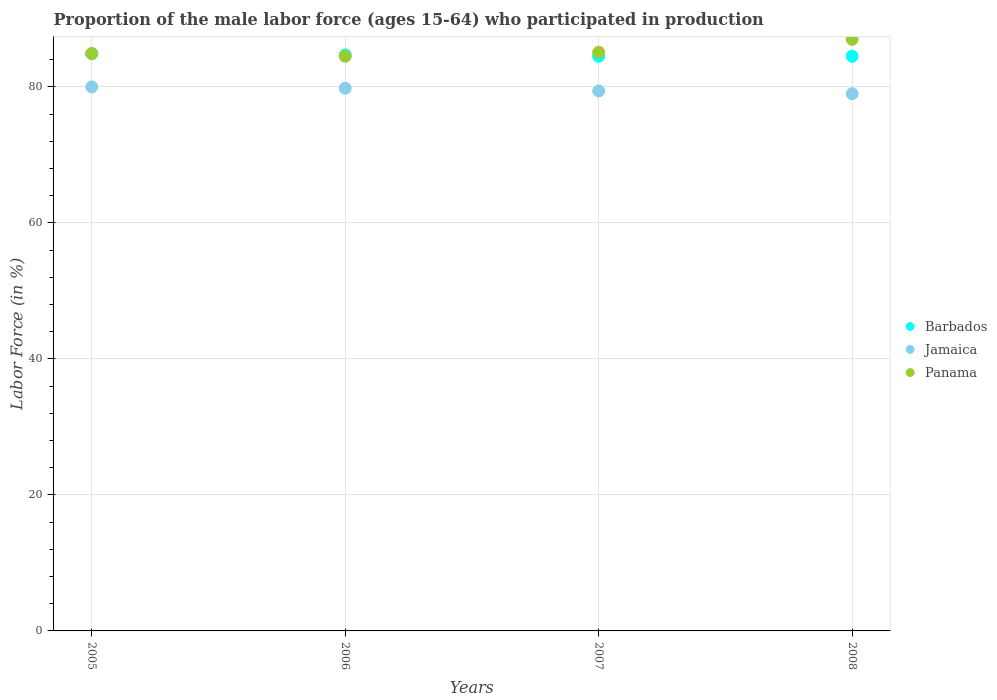How many different coloured dotlines are there?
Your answer should be very brief. 3. Is the number of dotlines equal to the number of legend labels?
Offer a very short reply. Yes. What is the proportion of the male labor force who participated in production in Jamaica in 2006?
Your answer should be very brief. 79.8. Across all years, what is the maximum proportion of the male labor force who participated in production in Barbados?
Give a very brief answer. 84.9. Across all years, what is the minimum proportion of the male labor force who participated in production in Barbados?
Make the answer very short. 84.5. In which year was the proportion of the male labor force who participated in production in Barbados maximum?
Your answer should be compact. 2005. What is the total proportion of the male labor force who participated in production in Jamaica in the graph?
Your response must be concise. 318.2. What is the difference between the proportion of the male labor force who participated in production in Jamaica in 2006 and that in 2007?
Give a very brief answer. 0.4. What is the difference between the proportion of the male labor force who participated in production in Barbados in 2006 and the proportion of the male labor force who participated in production in Jamaica in 2007?
Give a very brief answer. 5.3. What is the average proportion of the male labor force who participated in production in Barbados per year?
Provide a short and direct response. 84.65. In the year 2006, what is the difference between the proportion of the male labor force who participated in production in Panama and proportion of the male labor force who participated in production in Barbados?
Offer a very short reply. -0.2. What is the ratio of the proportion of the male labor force who participated in production in Panama in 2005 to that in 2007?
Provide a short and direct response. 1. What is the difference between the highest and the second highest proportion of the male labor force who participated in production in Panama?
Your answer should be very brief. 1.9. What is the difference between the highest and the lowest proportion of the male labor force who participated in production in Barbados?
Provide a succinct answer. 0.4. In how many years, is the proportion of the male labor force who participated in production in Barbados greater than the average proportion of the male labor force who participated in production in Barbados taken over all years?
Your answer should be very brief. 2. Is the sum of the proportion of the male labor force who participated in production in Jamaica in 2006 and 2007 greater than the maximum proportion of the male labor force who participated in production in Panama across all years?
Your answer should be very brief. Yes. Is it the case that in every year, the sum of the proportion of the male labor force who participated in production in Barbados and proportion of the male labor force who participated in production in Jamaica  is greater than the proportion of the male labor force who participated in production in Panama?
Offer a terse response. Yes. Does the proportion of the male labor force who participated in production in Panama monotonically increase over the years?
Ensure brevity in your answer.  No. Is the proportion of the male labor force who participated in production in Jamaica strictly greater than the proportion of the male labor force who participated in production in Panama over the years?
Offer a terse response. No. How many dotlines are there?
Give a very brief answer. 3. What is the difference between two consecutive major ticks on the Y-axis?
Provide a short and direct response. 20. How many legend labels are there?
Your response must be concise. 3. What is the title of the graph?
Provide a short and direct response. Proportion of the male labor force (ages 15-64) who participated in production. Does "Saudi Arabia" appear as one of the legend labels in the graph?
Give a very brief answer. No. What is the label or title of the X-axis?
Offer a terse response. Years. What is the Labor Force (in %) in Barbados in 2005?
Your answer should be very brief. 84.9. What is the Labor Force (in %) in Panama in 2005?
Provide a short and direct response. 84.9. What is the Labor Force (in %) of Barbados in 2006?
Provide a succinct answer. 84.7. What is the Labor Force (in %) of Jamaica in 2006?
Make the answer very short. 79.8. What is the Labor Force (in %) in Panama in 2006?
Keep it short and to the point. 84.5. What is the Labor Force (in %) of Barbados in 2007?
Your answer should be very brief. 84.5. What is the Labor Force (in %) in Jamaica in 2007?
Keep it short and to the point. 79.4. What is the Labor Force (in %) of Panama in 2007?
Your answer should be very brief. 85.1. What is the Labor Force (in %) of Barbados in 2008?
Your response must be concise. 84.5. What is the Labor Force (in %) of Jamaica in 2008?
Ensure brevity in your answer.  79. Across all years, what is the maximum Labor Force (in %) in Barbados?
Ensure brevity in your answer.  84.9. Across all years, what is the maximum Labor Force (in %) in Jamaica?
Your answer should be very brief. 80. Across all years, what is the maximum Labor Force (in %) in Panama?
Offer a very short reply. 87. Across all years, what is the minimum Labor Force (in %) of Barbados?
Give a very brief answer. 84.5. Across all years, what is the minimum Labor Force (in %) in Jamaica?
Offer a very short reply. 79. Across all years, what is the minimum Labor Force (in %) of Panama?
Give a very brief answer. 84.5. What is the total Labor Force (in %) of Barbados in the graph?
Make the answer very short. 338.6. What is the total Labor Force (in %) in Jamaica in the graph?
Offer a very short reply. 318.2. What is the total Labor Force (in %) in Panama in the graph?
Provide a short and direct response. 341.5. What is the difference between the Labor Force (in %) in Barbados in 2005 and that in 2006?
Offer a terse response. 0.2. What is the difference between the Labor Force (in %) in Panama in 2005 and that in 2006?
Your answer should be very brief. 0.4. What is the difference between the Labor Force (in %) in Barbados in 2005 and that in 2007?
Ensure brevity in your answer.  0.4. What is the difference between the Labor Force (in %) of Panama in 2005 and that in 2007?
Provide a short and direct response. -0.2. What is the difference between the Labor Force (in %) in Jamaica in 2005 and that in 2008?
Offer a terse response. 1. What is the difference between the Labor Force (in %) of Panama in 2005 and that in 2008?
Offer a very short reply. -2.1. What is the difference between the Labor Force (in %) of Jamaica in 2006 and that in 2007?
Offer a terse response. 0.4. What is the difference between the Labor Force (in %) of Panama in 2006 and that in 2007?
Offer a terse response. -0.6. What is the difference between the Labor Force (in %) of Jamaica in 2006 and that in 2008?
Your answer should be very brief. 0.8. What is the difference between the Labor Force (in %) of Panama in 2006 and that in 2008?
Your response must be concise. -2.5. What is the difference between the Labor Force (in %) of Barbados in 2007 and that in 2008?
Provide a short and direct response. 0. What is the difference between the Labor Force (in %) of Jamaica in 2007 and that in 2008?
Ensure brevity in your answer.  0.4. What is the difference between the Labor Force (in %) of Panama in 2007 and that in 2008?
Keep it short and to the point. -1.9. What is the difference between the Labor Force (in %) of Barbados in 2005 and the Labor Force (in %) of Jamaica in 2006?
Your answer should be very brief. 5.1. What is the difference between the Labor Force (in %) in Barbados in 2005 and the Labor Force (in %) in Panama in 2006?
Offer a very short reply. 0.4. What is the difference between the Labor Force (in %) in Barbados in 2005 and the Labor Force (in %) in Panama in 2007?
Offer a terse response. -0.2. What is the difference between the Labor Force (in %) in Jamaica in 2005 and the Labor Force (in %) in Panama in 2007?
Provide a succinct answer. -5.1. What is the difference between the Labor Force (in %) in Jamaica in 2005 and the Labor Force (in %) in Panama in 2008?
Your response must be concise. -7. What is the difference between the Labor Force (in %) in Jamaica in 2006 and the Labor Force (in %) in Panama in 2008?
Your answer should be very brief. -7.2. What is the difference between the Labor Force (in %) in Barbados in 2007 and the Labor Force (in %) in Panama in 2008?
Give a very brief answer. -2.5. What is the difference between the Labor Force (in %) in Jamaica in 2007 and the Labor Force (in %) in Panama in 2008?
Offer a very short reply. -7.6. What is the average Labor Force (in %) of Barbados per year?
Offer a very short reply. 84.65. What is the average Labor Force (in %) in Jamaica per year?
Offer a terse response. 79.55. What is the average Labor Force (in %) of Panama per year?
Provide a short and direct response. 85.38. In the year 2005, what is the difference between the Labor Force (in %) in Barbados and Labor Force (in %) in Jamaica?
Ensure brevity in your answer.  4.9. In the year 2005, what is the difference between the Labor Force (in %) of Barbados and Labor Force (in %) of Panama?
Your answer should be very brief. 0. In the year 2006, what is the difference between the Labor Force (in %) in Barbados and Labor Force (in %) in Jamaica?
Your response must be concise. 4.9. In the year 2006, what is the difference between the Labor Force (in %) of Barbados and Labor Force (in %) of Panama?
Your answer should be very brief. 0.2. In the year 2007, what is the difference between the Labor Force (in %) of Barbados and Labor Force (in %) of Jamaica?
Your answer should be very brief. 5.1. In the year 2007, what is the difference between the Labor Force (in %) in Barbados and Labor Force (in %) in Panama?
Your response must be concise. -0.6. In the year 2007, what is the difference between the Labor Force (in %) in Jamaica and Labor Force (in %) in Panama?
Offer a very short reply. -5.7. In the year 2008, what is the difference between the Labor Force (in %) in Barbados and Labor Force (in %) in Jamaica?
Provide a short and direct response. 5.5. In the year 2008, what is the difference between the Labor Force (in %) of Barbados and Labor Force (in %) of Panama?
Your answer should be very brief. -2.5. What is the ratio of the Labor Force (in %) of Barbados in 2005 to that in 2006?
Your response must be concise. 1. What is the ratio of the Labor Force (in %) in Panama in 2005 to that in 2006?
Keep it short and to the point. 1. What is the ratio of the Labor Force (in %) of Jamaica in 2005 to that in 2007?
Keep it short and to the point. 1.01. What is the ratio of the Labor Force (in %) in Jamaica in 2005 to that in 2008?
Your answer should be very brief. 1.01. What is the ratio of the Labor Force (in %) of Panama in 2005 to that in 2008?
Your response must be concise. 0.98. What is the ratio of the Labor Force (in %) in Barbados in 2006 to that in 2007?
Your answer should be very brief. 1. What is the ratio of the Labor Force (in %) in Panama in 2006 to that in 2008?
Provide a succinct answer. 0.97. What is the ratio of the Labor Force (in %) of Panama in 2007 to that in 2008?
Your answer should be very brief. 0.98. What is the difference between the highest and the second highest Labor Force (in %) of Barbados?
Your answer should be very brief. 0.2. What is the difference between the highest and the second highest Labor Force (in %) of Panama?
Your response must be concise. 1.9. What is the difference between the highest and the lowest Labor Force (in %) of Barbados?
Offer a very short reply. 0.4. What is the difference between the highest and the lowest Labor Force (in %) in Jamaica?
Your answer should be very brief. 1. What is the difference between the highest and the lowest Labor Force (in %) in Panama?
Provide a succinct answer. 2.5. 